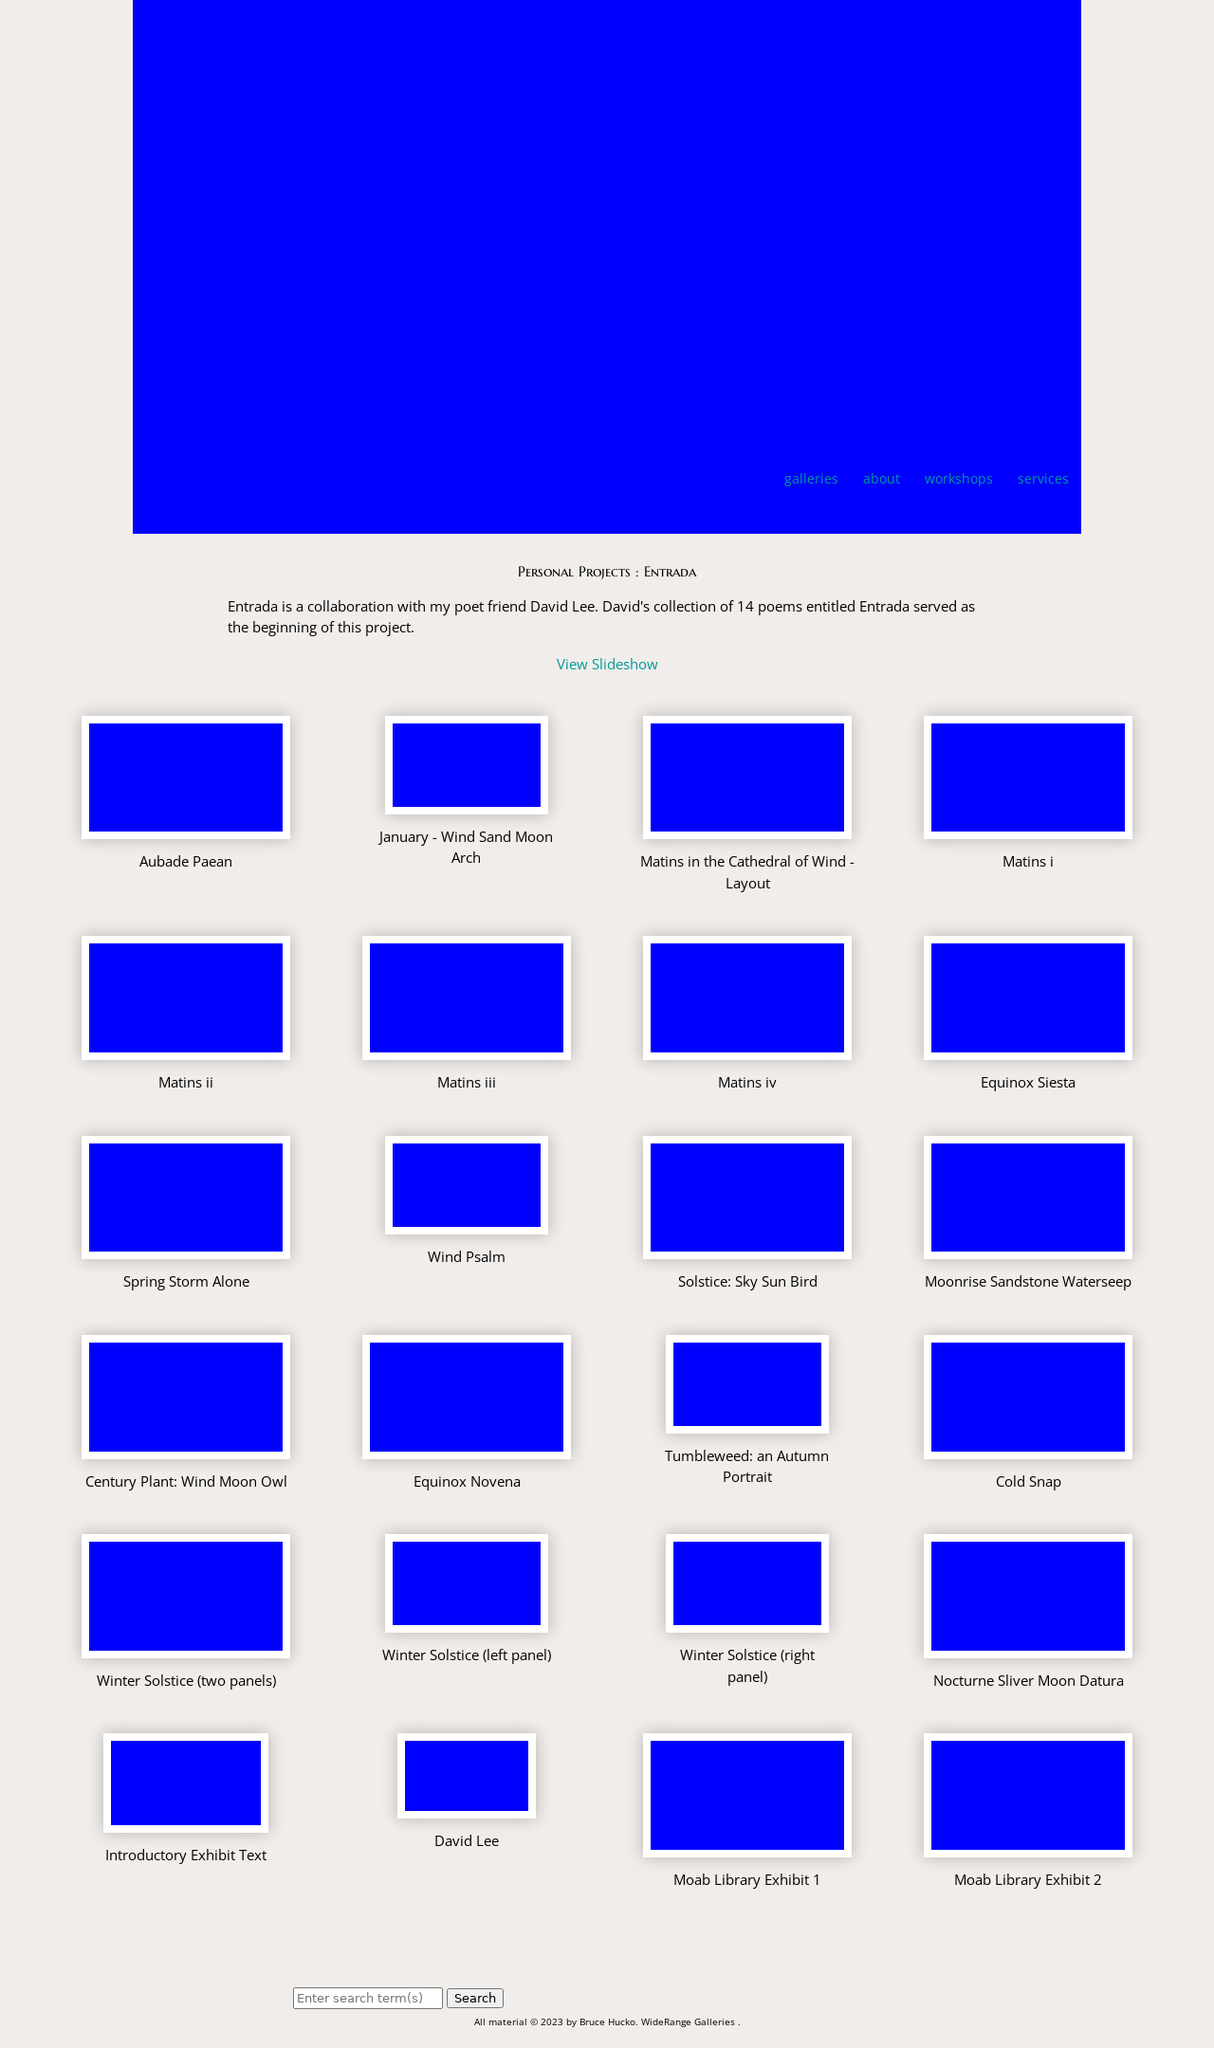Could you detail the process for assembling this website using HTML? To assemble a website like the one shown in the image using HTML, you would start by defining the structure with HTML to layout various elements like the sections for galleries, personal projects, and contact info. Next, CSS would be used for styling, applying colors, layouts, and fonts consistent with the design seen in the image. JavaScript might be added to handle interactive elements like the slideshow and responsive layouts. Key steps include setting up a navigational menu, organizing content in grids for projects and galleries, and ensuring the site is responsive for different device screens. 